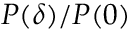<formula> <loc_0><loc_0><loc_500><loc_500>P ( \delta ) / P ( 0 )</formula> 